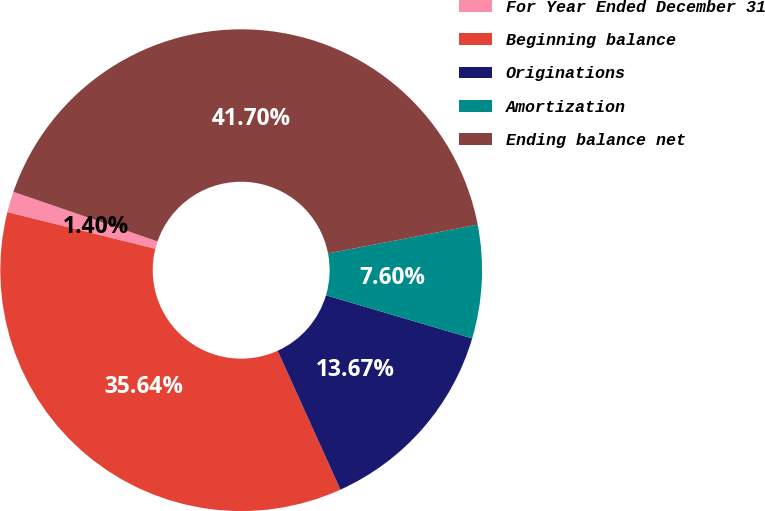Convert chart. <chart><loc_0><loc_0><loc_500><loc_500><pie_chart><fcel>For Year Ended December 31<fcel>Beginning balance<fcel>Originations<fcel>Amortization<fcel>Ending balance net<nl><fcel>1.4%<fcel>35.64%<fcel>13.67%<fcel>7.6%<fcel>41.7%<nl></chart> 